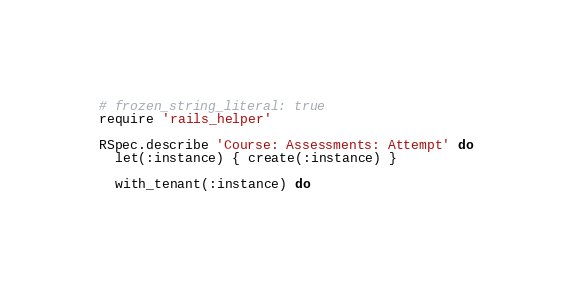Convert code to text. <code><loc_0><loc_0><loc_500><loc_500><_Ruby_># frozen_string_literal: true
require 'rails_helper'

RSpec.describe 'Course: Assessments: Attempt' do
  let(:instance) { create(:instance) }

  with_tenant(:instance) do</code> 